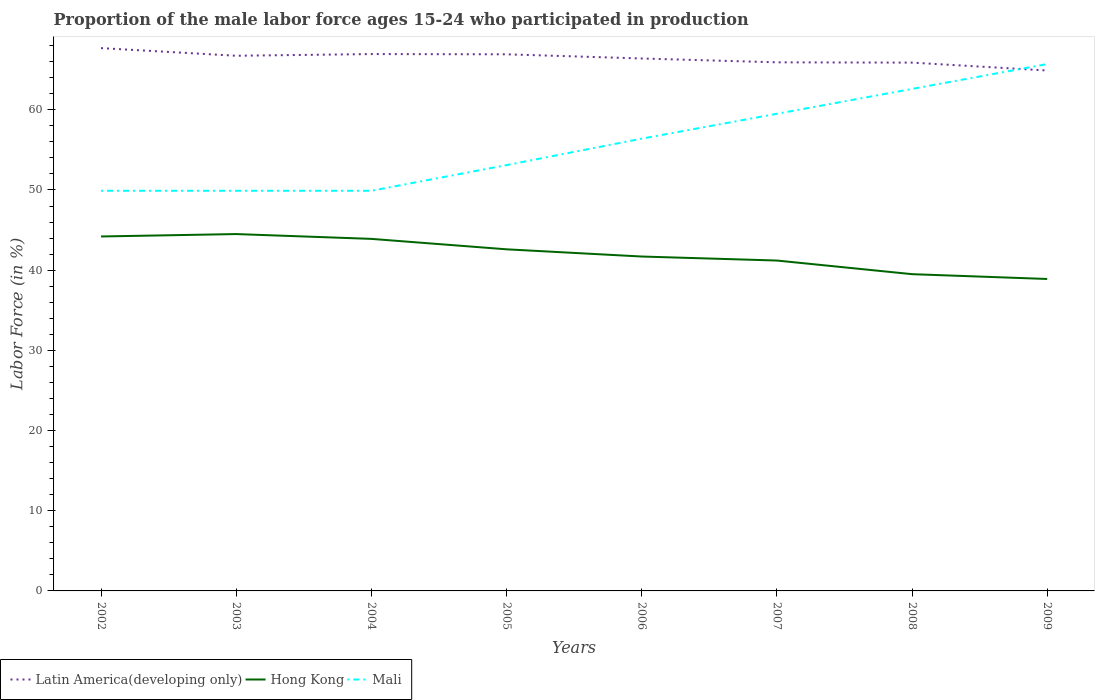How many different coloured lines are there?
Ensure brevity in your answer.  3. Does the line corresponding to Hong Kong intersect with the line corresponding to Latin America(developing only)?
Your response must be concise. No. Across all years, what is the maximum proportion of the male labor force who participated in production in Latin America(developing only)?
Your answer should be compact. 64.9. What is the total proportion of the male labor force who participated in production in Latin America(developing only) in the graph?
Your answer should be compact. 1. What is the difference between the highest and the second highest proportion of the male labor force who participated in production in Hong Kong?
Offer a terse response. 5.6. What is the difference between two consecutive major ticks on the Y-axis?
Offer a terse response. 10. Where does the legend appear in the graph?
Provide a succinct answer. Bottom left. How are the legend labels stacked?
Provide a short and direct response. Horizontal. What is the title of the graph?
Keep it short and to the point. Proportion of the male labor force ages 15-24 who participated in production. What is the label or title of the Y-axis?
Keep it short and to the point. Labor Force (in %). What is the Labor Force (in %) of Latin America(developing only) in 2002?
Give a very brief answer. 67.69. What is the Labor Force (in %) in Hong Kong in 2002?
Make the answer very short. 44.2. What is the Labor Force (in %) of Mali in 2002?
Offer a very short reply. 49.9. What is the Labor Force (in %) in Latin America(developing only) in 2003?
Provide a short and direct response. 66.74. What is the Labor Force (in %) of Hong Kong in 2003?
Your response must be concise. 44.5. What is the Labor Force (in %) in Mali in 2003?
Give a very brief answer. 49.9. What is the Labor Force (in %) in Latin America(developing only) in 2004?
Ensure brevity in your answer.  66.95. What is the Labor Force (in %) in Hong Kong in 2004?
Provide a succinct answer. 43.9. What is the Labor Force (in %) in Mali in 2004?
Ensure brevity in your answer.  49.9. What is the Labor Force (in %) in Latin America(developing only) in 2005?
Give a very brief answer. 66.92. What is the Labor Force (in %) of Hong Kong in 2005?
Your answer should be very brief. 42.6. What is the Labor Force (in %) in Mali in 2005?
Keep it short and to the point. 53.1. What is the Labor Force (in %) in Latin America(developing only) in 2006?
Give a very brief answer. 66.4. What is the Labor Force (in %) in Hong Kong in 2006?
Keep it short and to the point. 41.7. What is the Labor Force (in %) of Mali in 2006?
Offer a terse response. 56.4. What is the Labor Force (in %) in Latin America(developing only) in 2007?
Provide a short and direct response. 65.92. What is the Labor Force (in %) in Hong Kong in 2007?
Provide a succinct answer. 41.2. What is the Labor Force (in %) of Mali in 2007?
Your response must be concise. 59.5. What is the Labor Force (in %) in Latin America(developing only) in 2008?
Provide a short and direct response. 65.88. What is the Labor Force (in %) in Hong Kong in 2008?
Offer a very short reply. 39.5. What is the Labor Force (in %) of Mali in 2008?
Offer a very short reply. 62.6. What is the Labor Force (in %) in Latin America(developing only) in 2009?
Keep it short and to the point. 64.9. What is the Labor Force (in %) of Hong Kong in 2009?
Your answer should be very brief. 38.9. What is the Labor Force (in %) in Mali in 2009?
Give a very brief answer. 65.7. Across all years, what is the maximum Labor Force (in %) of Latin America(developing only)?
Your response must be concise. 67.69. Across all years, what is the maximum Labor Force (in %) of Hong Kong?
Your answer should be compact. 44.5. Across all years, what is the maximum Labor Force (in %) in Mali?
Ensure brevity in your answer.  65.7. Across all years, what is the minimum Labor Force (in %) of Latin America(developing only)?
Offer a very short reply. 64.9. Across all years, what is the minimum Labor Force (in %) of Hong Kong?
Your answer should be compact. 38.9. Across all years, what is the minimum Labor Force (in %) in Mali?
Your answer should be very brief. 49.9. What is the total Labor Force (in %) of Latin America(developing only) in the graph?
Your answer should be compact. 531.38. What is the total Labor Force (in %) in Hong Kong in the graph?
Your answer should be very brief. 336.5. What is the total Labor Force (in %) of Mali in the graph?
Your answer should be very brief. 447. What is the difference between the Labor Force (in %) of Hong Kong in 2002 and that in 2003?
Your answer should be compact. -0.3. What is the difference between the Labor Force (in %) in Mali in 2002 and that in 2003?
Offer a very short reply. 0. What is the difference between the Labor Force (in %) of Latin America(developing only) in 2002 and that in 2004?
Offer a terse response. 0.74. What is the difference between the Labor Force (in %) of Hong Kong in 2002 and that in 2004?
Your answer should be compact. 0.3. What is the difference between the Labor Force (in %) of Latin America(developing only) in 2002 and that in 2005?
Provide a succinct answer. 0.77. What is the difference between the Labor Force (in %) in Latin America(developing only) in 2002 and that in 2006?
Provide a short and direct response. 1.29. What is the difference between the Labor Force (in %) in Mali in 2002 and that in 2006?
Give a very brief answer. -6.5. What is the difference between the Labor Force (in %) of Latin America(developing only) in 2002 and that in 2007?
Offer a very short reply. 1.77. What is the difference between the Labor Force (in %) in Mali in 2002 and that in 2007?
Provide a succinct answer. -9.6. What is the difference between the Labor Force (in %) of Latin America(developing only) in 2002 and that in 2008?
Offer a very short reply. 1.81. What is the difference between the Labor Force (in %) of Mali in 2002 and that in 2008?
Your response must be concise. -12.7. What is the difference between the Labor Force (in %) in Latin America(developing only) in 2002 and that in 2009?
Provide a succinct answer. 2.79. What is the difference between the Labor Force (in %) in Mali in 2002 and that in 2009?
Offer a terse response. -15.8. What is the difference between the Labor Force (in %) of Latin America(developing only) in 2003 and that in 2004?
Offer a terse response. -0.21. What is the difference between the Labor Force (in %) in Hong Kong in 2003 and that in 2004?
Make the answer very short. 0.6. What is the difference between the Labor Force (in %) in Mali in 2003 and that in 2004?
Keep it short and to the point. 0. What is the difference between the Labor Force (in %) of Latin America(developing only) in 2003 and that in 2005?
Provide a short and direct response. -0.18. What is the difference between the Labor Force (in %) in Hong Kong in 2003 and that in 2005?
Offer a terse response. 1.9. What is the difference between the Labor Force (in %) of Latin America(developing only) in 2003 and that in 2006?
Ensure brevity in your answer.  0.34. What is the difference between the Labor Force (in %) of Latin America(developing only) in 2003 and that in 2007?
Offer a terse response. 0.82. What is the difference between the Labor Force (in %) of Hong Kong in 2003 and that in 2007?
Provide a succinct answer. 3.3. What is the difference between the Labor Force (in %) of Mali in 2003 and that in 2007?
Your answer should be compact. -9.6. What is the difference between the Labor Force (in %) of Latin America(developing only) in 2003 and that in 2008?
Give a very brief answer. 0.86. What is the difference between the Labor Force (in %) in Hong Kong in 2003 and that in 2008?
Your response must be concise. 5. What is the difference between the Labor Force (in %) of Mali in 2003 and that in 2008?
Offer a very short reply. -12.7. What is the difference between the Labor Force (in %) in Latin America(developing only) in 2003 and that in 2009?
Offer a very short reply. 1.84. What is the difference between the Labor Force (in %) in Mali in 2003 and that in 2009?
Provide a short and direct response. -15.8. What is the difference between the Labor Force (in %) in Latin America(developing only) in 2004 and that in 2005?
Make the answer very short. 0.03. What is the difference between the Labor Force (in %) in Hong Kong in 2004 and that in 2005?
Give a very brief answer. 1.3. What is the difference between the Labor Force (in %) of Mali in 2004 and that in 2005?
Provide a short and direct response. -3.2. What is the difference between the Labor Force (in %) of Latin America(developing only) in 2004 and that in 2006?
Your answer should be very brief. 0.55. What is the difference between the Labor Force (in %) of Hong Kong in 2004 and that in 2006?
Keep it short and to the point. 2.2. What is the difference between the Labor Force (in %) of Latin America(developing only) in 2004 and that in 2007?
Give a very brief answer. 1.03. What is the difference between the Labor Force (in %) of Latin America(developing only) in 2004 and that in 2008?
Give a very brief answer. 1.07. What is the difference between the Labor Force (in %) of Mali in 2004 and that in 2008?
Your response must be concise. -12.7. What is the difference between the Labor Force (in %) in Latin America(developing only) in 2004 and that in 2009?
Offer a terse response. 2.05. What is the difference between the Labor Force (in %) in Mali in 2004 and that in 2009?
Offer a terse response. -15.8. What is the difference between the Labor Force (in %) of Latin America(developing only) in 2005 and that in 2006?
Offer a very short reply. 0.52. What is the difference between the Labor Force (in %) in Mali in 2005 and that in 2006?
Your response must be concise. -3.3. What is the difference between the Labor Force (in %) of Hong Kong in 2005 and that in 2007?
Make the answer very short. 1.4. What is the difference between the Labor Force (in %) in Mali in 2005 and that in 2007?
Ensure brevity in your answer.  -6.4. What is the difference between the Labor Force (in %) of Latin America(developing only) in 2005 and that in 2008?
Make the answer very short. 1.04. What is the difference between the Labor Force (in %) in Mali in 2005 and that in 2008?
Your answer should be compact. -9.5. What is the difference between the Labor Force (in %) of Latin America(developing only) in 2005 and that in 2009?
Give a very brief answer. 2.02. What is the difference between the Labor Force (in %) of Hong Kong in 2005 and that in 2009?
Offer a very short reply. 3.7. What is the difference between the Labor Force (in %) of Mali in 2005 and that in 2009?
Offer a very short reply. -12.6. What is the difference between the Labor Force (in %) in Latin America(developing only) in 2006 and that in 2007?
Offer a terse response. 0.48. What is the difference between the Labor Force (in %) in Mali in 2006 and that in 2007?
Give a very brief answer. -3.1. What is the difference between the Labor Force (in %) in Latin America(developing only) in 2006 and that in 2008?
Make the answer very short. 0.52. What is the difference between the Labor Force (in %) in Latin America(developing only) in 2006 and that in 2009?
Provide a short and direct response. 1.5. What is the difference between the Labor Force (in %) of Hong Kong in 2006 and that in 2009?
Offer a very short reply. 2.8. What is the difference between the Labor Force (in %) in Latin America(developing only) in 2007 and that in 2008?
Offer a very short reply. 0.04. What is the difference between the Labor Force (in %) of Hong Kong in 2007 and that in 2008?
Offer a very short reply. 1.7. What is the difference between the Labor Force (in %) in Mali in 2007 and that in 2008?
Your answer should be very brief. -3.1. What is the difference between the Labor Force (in %) in Latin America(developing only) in 2007 and that in 2009?
Your answer should be very brief. 1.02. What is the difference between the Labor Force (in %) of Hong Kong in 2007 and that in 2009?
Your response must be concise. 2.3. What is the difference between the Labor Force (in %) of Latin America(developing only) in 2008 and that in 2009?
Your answer should be compact. 0.98. What is the difference between the Labor Force (in %) of Hong Kong in 2008 and that in 2009?
Keep it short and to the point. 0.6. What is the difference between the Labor Force (in %) of Latin America(developing only) in 2002 and the Labor Force (in %) of Hong Kong in 2003?
Offer a terse response. 23.19. What is the difference between the Labor Force (in %) of Latin America(developing only) in 2002 and the Labor Force (in %) of Mali in 2003?
Make the answer very short. 17.79. What is the difference between the Labor Force (in %) in Hong Kong in 2002 and the Labor Force (in %) in Mali in 2003?
Offer a terse response. -5.7. What is the difference between the Labor Force (in %) in Latin America(developing only) in 2002 and the Labor Force (in %) in Hong Kong in 2004?
Provide a succinct answer. 23.79. What is the difference between the Labor Force (in %) of Latin America(developing only) in 2002 and the Labor Force (in %) of Mali in 2004?
Your answer should be compact. 17.79. What is the difference between the Labor Force (in %) of Latin America(developing only) in 2002 and the Labor Force (in %) of Hong Kong in 2005?
Provide a short and direct response. 25.09. What is the difference between the Labor Force (in %) of Latin America(developing only) in 2002 and the Labor Force (in %) of Mali in 2005?
Ensure brevity in your answer.  14.59. What is the difference between the Labor Force (in %) of Latin America(developing only) in 2002 and the Labor Force (in %) of Hong Kong in 2006?
Keep it short and to the point. 25.99. What is the difference between the Labor Force (in %) of Latin America(developing only) in 2002 and the Labor Force (in %) of Mali in 2006?
Your answer should be compact. 11.29. What is the difference between the Labor Force (in %) in Hong Kong in 2002 and the Labor Force (in %) in Mali in 2006?
Make the answer very short. -12.2. What is the difference between the Labor Force (in %) of Latin America(developing only) in 2002 and the Labor Force (in %) of Hong Kong in 2007?
Offer a terse response. 26.49. What is the difference between the Labor Force (in %) in Latin America(developing only) in 2002 and the Labor Force (in %) in Mali in 2007?
Keep it short and to the point. 8.19. What is the difference between the Labor Force (in %) of Hong Kong in 2002 and the Labor Force (in %) of Mali in 2007?
Make the answer very short. -15.3. What is the difference between the Labor Force (in %) of Latin America(developing only) in 2002 and the Labor Force (in %) of Hong Kong in 2008?
Provide a short and direct response. 28.19. What is the difference between the Labor Force (in %) of Latin America(developing only) in 2002 and the Labor Force (in %) of Mali in 2008?
Provide a short and direct response. 5.09. What is the difference between the Labor Force (in %) in Hong Kong in 2002 and the Labor Force (in %) in Mali in 2008?
Provide a succinct answer. -18.4. What is the difference between the Labor Force (in %) of Latin America(developing only) in 2002 and the Labor Force (in %) of Hong Kong in 2009?
Your response must be concise. 28.79. What is the difference between the Labor Force (in %) in Latin America(developing only) in 2002 and the Labor Force (in %) in Mali in 2009?
Ensure brevity in your answer.  1.99. What is the difference between the Labor Force (in %) in Hong Kong in 2002 and the Labor Force (in %) in Mali in 2009?
Ensure brevity in your answer.  -21.5. What is the difference between the Labor Force (in %) in Latin America(developing only) in 2003 and the Labor Force (in %) in Hong Kong in 2004?
Ensure brevity in your answer.  22.84. What is the difference between the Labor Force (in %) in Latin America(developing only) in 2003 and the Labor Force (in %) in Mali in 2004?
Make the answer very short. 16.84. What is the difference between the Labor Force (in %) of Latin America(developing only) in 2003 and the Labor Force (in %) of Hong Kong in 2005?
Provide a succinct answer. 24.14. What is the difference between the Labor Force (in %) in Latin America(developing only) in 2003 and the Labor Force (in %) in Mali in 2005?
Your response must be concise. 13.64. What is the difference between the Labor Force (in %) in Latin America(developing only) in 2003 and the Labor Force (in %) in Hong Kong in 2006?
Your response must be concise. 25.04. What is the difference between the Labor Force (in %) of Latin America(developing only) in 2003 and the Labor Force (in %) of Mali in 2006?
Offer a terse response. 10.34. What is the difference between the Labor Force (in %) in Latin America(developing only) in 2003 and the Labor Force (in %) in Hong Kong in 2007?
Keep it short and to the point. 25.54. What is the difference between the Labor Force (in %) in Latin America(developing only) in 2003 and the Labor Force (in %) in Mali in 2007?
Offer a very short reply. 7.24. What is the difference between the Labor Force (in %) of Latin America(developing only) in 2003 and the Labor Force (in %) of Hong Kong in 2008?
Make the answer very short. 27.24. What is the difference between the Labor Force (in %) in Latin America(developing only) in 2003 and the Labor Force (in %) in Mali in 2008?
Give a very brief answer. 4.14. What is the difference between the Labor Force (in %) of Hong Kong in 2003 and the Labor Force (in %) of Mali in 2008?
Your answer should be compact. -18.1. What is the difference between the Labor Force (in %) in Latin America(developing only) in 2003 and the Labor Force (in %) in Hong Kong in 2009?
Provide a short and direct response. 27.84. What is the difference between the Labor Force (in %) in Latin America(developing only) in 2003 and the Labor Force (in %) in Mali in 2009?
Keep it short and to the point. 1.04. What is the difference between the Labor Force (in %) of Hong Kong in 2003 and the Labor Force (in %) of Mali in 2009?
Provide a succinct answer. -21.2. What is the difference between the Labor Force (in %) in Latin America(developing only) in 2004 and the Labor Force (in %) in Hong Kong in 2005?
Offer a very short reply. 24.35. What is the difference between the Labor Force (in %) in Latin America(developing only) in 2004 and the Labor Force (in %) in Mali in 2005?
Offer a terse response. 13.85. What is the difference between the Labor Force (in %) in Hong Kong in 2004 and the Labor Force (in %) in Mali in 2005?
Ensure brevity in your answer.  -9.2. What is the difference between the Labor Force (in %) in Latin America(developing only) in 2004 and the Labor Force (in %) in Hong Kong in 2006?
Your answer should be very brief. 25.25. What is the difference between the Labor Force (in %) in Latin America(developing only) in 2004 and the Labor Force (in %) in Mali in 2006?
Make the answer very short. 10.55. What is the difference between the Labor Force (in %) in Latin America(developing only) in 2004 and the Labor Force (in %) in Hong Kong in 2007?
Provide a succinct answer. 25.75. What is the difference between the Labor Force (in %) of Latin America(developing only) in 2004 and the Labor Force (in %) of Mali in 2007?
Give a very brief answer. 7.45. What is the difference between the Labor Force (in %) in Hong Kong in 2004 and the Labor Force (in %) in Mali in 2007?
Your answer should be compact. -15.6. What is the difference between the Labor Force (in %) of Latin America(developing only) in 2004 and the Labor Force (in %) of Hong Kong in 2008?
Keep it short and to the point. 27.45. What is the difference between the Labor Force (in %) of Latin America(developing only) in 2004 and the Labor Force (in %) of Mali in 2008?
Your response must be concise. 4.35. What is the difference between the Labor Force (in %) of Hong Kong in 2004 and the Labor Force (in %) of Mali in 2008?
Provide a succinct answer. -18.7. What is the difference between the Labor Force (in %) of Latin America(developing only) in 2004 and the Labor Force (in %) of Hong Kong in 2009?
Give a very brief answer. 28.05. What is the difference between the Labor Force (in %) of Latin America(developing only) in 2004 and the Labor Force (in %) of Mali in 2009?
Your response must be concise. 1.25. What is the difference between the Labor Force (in %) of Hong Kong in 2004 and the Labor Force (in %) of Mali in 2009?
Your answer should be compact. -21.8. What is the difference between the Labor Force (in %) in Latin America(developing only) in 2005 and the Labor Force (in %) in Hong Kong in 2006?
Your response must be concise. 25.22. What is the difference between the Labor Force (in %) of Latin America(developing only) in 2005 and the Labor Force (in %) of Mali in 2006?
Keep it short and to the point. 10.52. What is the difference between the Labor Force (in %) in Hong Kong in 2005 and the Labor Force (in %) in Mali in 2006?
Provide a short and direct response. -13.8. What is the difference between the Labor Force (in %) in Latin America(developing only) in 2005 and the Labor Force (in %) in Hong Kong in 2007?
Offer a very short reply. 25.72. What is the difference between the Labor Force (in %) of Latin America(developing only) in 2005 and the Labor Force (in %) of Mali in 2007?
Give a very brief answer. 7.42. What is the difference between the Labor Force (in %) of Hong Kong in 2005 and the Labor Force (in %) of Mali in 2007?
Provide a succinct answer. -16.9. What is the difference between the Labor Force (in %) in Latin America(developing only) in 2005 and the Labor Force (in %) in Hong Kong in 2008?
Your answer should be very brief. 27.42. What is the difference between the Labor Force (in %) in Latin America(developing only) in 2005 and the Labor Force (in %) in Mali in 2008?
Give a very brief answer. 4.32. What is the difference between the Labor Force (in %) of Latin America(developing only) in 2005 and the Labor Force (in %) of Hong Kong in 2009?
Your answer should be compact. 28.02. What is the difference between the Labor Force (in %) of Latin America(developing only) in 2005 and the Labor Force (in %) of Mali in 2009?
Offer a terse response. 1.22. What is the difference between the Labor Force (in %) of Hong Kong in 2005 and the Labor Force (in %) of Mali in 2009?
Keep it short and to the point. -23.1. What is the difference between the Labor Force (in %) of Latin America(developing only) in 2006 and the Labor Force (in %) of Hong Kong in 2007?
Keep it short and to the point. 25.2. What is the difference between the Labor Force (in %) of Latin America(developing only) in 2006 and the Labor Force (in %) of Mali in 2007?
Your answer should be compact. 6.9. What is the difference between the Labor Force (in %) in Hong Kong in 2006 and the Labor Force (in %) in Mali in 2007?
Your response must be concise. -17.8. What is the difference between the Labor Force (in %) in Latin America(developing only) in 2006 and the Labor Force (in %) in Hong Kong in 2008?
Provide a short and direct response. 26.9. What is the difference between the Labor Force (in %) of Latin America(developing only) in 2006 and the Labor Force (in %) of Mali in 2008?
Provide a succinct answer. 3.8. What is the difference between the Labor Force (in %) in Hong Kong in 2006 and the Labor Force (in %) in Mali in 2008?
Give a very brief answer. -20.9. What is the difference between the Labor Force (in %) in Latin America(developing only) in 2006 and the Labor Force (in %) in Hong Kong in 2009?
Your response must be concise. 27.5. What is the difference between the Labor Force (in %) of Latin America(developing only) in 2006 and the Labor Force (in %) of Mali in 2009?
Keep it short and to the point. 0.7. What is the difference between the Labor Force (in %) in Latin America(developing only) in 2007 and the Labor Force (in %) in Hong Kong in 2008?
Make the answer very short. 26.42. What is the difference between the Labor Force (in %) in Latin America(developing only) in 2007 and the Labor Force (in %) in Mali in 2008?
Offer a terse response. 3.32. What is the difference between the Labor Force (in %) of Hong Kong in 2007 and the Labor Force (in %) of Mali in 2008?
Offer a very short reply. -21.4. What is the difference between the Labor Force (in %) in Latin America(developing only) in 2007 and the Labor Force (in %) in Hong Kong in 2009?
Ensure brevity in your answer.  27.02. What is the difference between the Labor Force (in %) of Latin America(developing only) in 2007 and the Labor Force (in %) of Mali in 2009?
Ensure brevity in your answer.  0.22. What is the difference between the Labor Force (in %) in Hong Kong in 2007 and the Labor Force (in %) in Mali in 2009?
Keep it short and to the point. -24.5. What is the difference between the Labor Force (in %) in Latin America(developing only) in 2008 and the Labor Force (in %) in Hong Kong in 2009?
Give a very brief answer. 26.98. What is the difference between the Labor Force (in %) of Latin America(developing only) in 2008 and the Labor Force (in %) of Mali in 2009?
Offer a terse response. 0.18. What is the difference between the Labor Force (in %) of Hong Kong in 2008 and the Labor Force (in %) of Mali in 2009?
Offer a terse response. -26.2. What is the average Labor Force (in %) of Latin America(developing only) per year?
Your answer should be compact. 66.42. What is the average Labor Force (in %) of Hong Kong per year?
Ensure brevity in your answer.  42.06. What is the average Labor Force (in %) in Mali per year?
Offer a terse response. 55.88. In the year 2002, what is the difference between the Labor Force (in %) of Latin America(developing only) and Labor Force (in %) of Hong Kong?
Offer a terse response. 23.49. In the year 2002, what is the difference between the Labor Force (in %) of Latin America(developing only) and Labor Force (in %) of Mali?
Your answer should be compact. 17.79. In the year 2003, what is the difference between the Labor Force (in %) of Latin America(developing only) and Labor Force (in %) of Hong Kong?
Ensure brevity in your answer.  22.24. In the year 2003, what is the difference between the Labor Force (in %) of Latin America(developing only) and Labor Force (in %) of Mali?
Your answer should be very brief. 16.84. In the year 2004, what is the difference between the Labor Force (in %) in Latin America(developing only) and Labor Force (in %) in Hong Kong?
Provide a succinct answer. 23.05. In the year 2004, what is the difference between the Labor Force (in %) in Latin America(developing only) and Labor Force (in %) in Mali?
Ensure brevity in your answer.  17.05. In the year 2004, what is the difference between the Labor Force (in %) of Hong Kong and Labor Force (in %) of Mali?
Your answer should be very brief. -6. In the year 2005, what is the difference between the Labor Force (in %) in Latin America(developing only) and Labor Force (in %) in Hong Kong?
Ensure brevity in your answer.  24.32. In the year 2005, what is the difference between the Labor Force (in %) of Latin America(developing only) and Labor Force (in %) of Mali?
Keep it short and to the point. 13.82. In the year 2005, what is the difference between the Labor Force (in %) in Hong Kong and Labor Force (in %) in Mali?
Your answer should be compact. -10.5. In the year 2006, what is the difference between the Labor Force (in %) of Latin America(developing only) and Labor Force (in %) of Hong Kong?
Your answer should be compact. 24.7. In the year 2006, what is the difference between the Labor Force (in %) in Latin America(developing only) and Labor Force (in %) in Mali?
Make the answer very short. 10. In the year 2006, what is the difference between the Labor Force (in %) of Hong Kong and Labor Force (in %) of Mali?
Provide a short and direct response. -14.7. In the year 2007, what is the difference between the Labor Force (in %) of Latin America(developing only) and Labor Force (in %) of Hong Kong?
Keep it short and to the point. 24.72. In the year 2007, what is the difference between the Labor Force (in %) of Latin America(developing only) and Labor Force (in %) of Mali?
Your response must be concise. 6.42. In the year 2007, what is the difference between the Labor Force (in %) of Hong Kong and Labor Force (in %) of Mali?
Offer a very short reply. -18.3. In the year 2008, what is the difference between the Labor Force (in %) of Latin America(developing only) and Labor Force (in %) of Hong Kong?
Provide a short and direct response. 26.38. In the year 2008, what is the difference between the Labor Force (in %) of Latin America(developing only) and Labor Force (in %) of Mali?
Give a very brief answer. 3.28. In the year 2008, what is the difference between the Labor Force (in %) in Hong Kong and Labor Force (in %) in Mali?
Make the answer very short. -23.1. In the year 2009, what is the difference between the Labor Force (in %) in Latin America(developing only) and Labor Force (in %) in Hong Kong?
Give a very brief answer. 26. In the year 2009, what is the difference between the Labor Force (in %) of Latin America(developing only) and Labor Force (in %) of Mali?
Make the answer very short. -0.8. In the year 2009, what is the difference between the Labor Force (in %) in Hong Kong and Labor Force (in %) in Mali?
Your answer should be very brief. -26.8. What is the ratio of the Labor Force (in %) in Latin America(developing only) in 2002 to that in 2003?
Give a very brief answer. 1.01. What is the ratio of the Labor Force (in %) of Mali in 2002 to that in 2003?
Provide a short and direct response. 1. What is the ratio of the Labor Force (in %) of Latin America(developing only) in 2002 to that in 2004?
Ensure brevity in your answer.  1.01. What is the ratio of the Labor Force (in %) in Hong Kong in 2002 to that in 2004?
Ensure brevity in your answer.  1.01. What is the ratio of the Labor Force (in %) of Mali in 2002 to that in 2004?
Offer a very short reply. 1. What is the ratio of the Labor Force (in %) in Latin America(developing only) in 2002 to that in 2005?
Provide a short and direct response. 1.01. What is the ratio of the Labor Force (in %) in Hong Kong in 2002 to that in 2005?
Your answer should be very brief. 1.04. What is the ratio of the Labor Force (in %) of Mali in 2002 to that in 2005?
Your response must be concise. 0.94. What is the ratio of the Labor Force (in %) of Latin America(developing only) in 2002 to that in 2006?
Your response must be concise. 1.02. What is the ratio of the Labor Force (in %) of Hong Kong in 2002 to that in 2006?
Your response must be concise. 1.06. What is the ratio of the Labor Force (in %) of Mali in 2002 to that in 2006?
Give a very brief answer. 0.88. What is the ratio of the Labor Force (in %) of Latin America(developing only) in 2002 to that in 2007?
Make the answer very short. 1.03. What is the ratio of the Labor Force (in %) of Hong Kong in 2002 to that in 2007?
Give a very brief answer. 1.07. What is the ratio of the Labor Force (in %) in Mali in 2002 to that in 2007?
Your response must be concise. 0.84. What is the ratio of the Labor Force (in %) of Latin America(developing only) in 2002 to that in 2008?
Provide a succinct answer. 1.03. What is the ratio of the Labor Force (in %) in Hong Kong in 2002 to that in 2008?
Give a very brief answer. 1.12. What is the ratio of the Labor Force (in %) in Mali in 2002 to that in 2008?
Your response must be concise. 0.8. What is the ratio of the Labor Force (in %) of Latin America(developing only) in 2002 to that in 2009?
Provide a short and direct response. 1.04. What is the ratio of the Labor Force (in %) in Hong Kong in 2002 to that in 2009?
Give a very brief answer. 1.14. What is the ratio of the Labor Force (in %) of Mali in 2002 to that in 2009?
Give a very brief answer. 0.76. What is the ratio of the Labor Force (in %) in Hong Kong in 2003 to that in 2004?
Provide a succinct answer. 1.01. What is the ratio of the Labor Force (in %) of Mali in 2003 to that in 2004?
Offer a terse response. 1. What is the ratio of the Labor Force (in %) of Latin America(developing only) in 2003 to that in 2005?
Ensure brevity in your answer.  1. What is the ratio of the Labor Force (in %) of Hong Kong in 2003 to that in 2005?
Your answer should be compact. 1.04. What is the ratio of the Labor Force (in %) of Mali in 2003 to that in 2005?
Your answer should be compact. 0.94. What is the ratio of the Labor Force (in %) of Hong Kong in 2003 to that in 2006?
Provide a succinct answer. 1.07. What is the ratio of the Labor Force (in %) of Mali in 2003 to that in 2006?
Your response must be concise. 0.88. What is the ratio of the Labor Force (in %) in Latin America(developing only) in 2003 to that in 2007?
Give a very brief answer. 1.01. What is the ratio of the Labor Force (in %) of Hong Kong in 2003 to that in 2007?
Offer a very short reply. 1.08. What is the ratio of the Labor Force (in %) of Mali in 2003 to that in 2007?
Your answer should be very brief. 0.84. What is the ratio of the Labor Force (in %) of Latin America(developing only) in 2003 to that in 2008?
Make the answer very short. 1.01. What is the ratio of the Labor Force (in %) of Hong Kong in 2003 to that in 2008?
Provide a short and direct response. 1.13. What is the ratio of the Labor Force (in %) of Mali in 2003 to that in 2008?
Keep it short and to the point. 0.8. What is the ratio of the Labor Force (in %) of Latin America(developing only) in 2003 to that in 2009?
Keep it short and to the point. 1.03. What is the ratio of the Labor Force (in %) of Hong Kong in 2003 to that in 2009?
Make the answer very short. 1.14. What is the ratio of the Labor Force (in %) of Mali in 2003 to that in 2009?
Offer a terse response. 0.76. What is the ratio of the Labor Force (in %) of Latin America(developing only) in 2004 to that in 2005?
Your answer should be compact. 1. What is the ratio of the Labor Force (in %) in Hong Kong in 2004 to that in 2005?
Keep it short and to the point. 1.03. What is the ratio of the Labor Force (in %) of Mali in 2004 to that in 2005?
Keep it short and to the point. 0.94. What is the ratio of the Labor Force (in %) in Latin America(developing only) in 2004 to that in 2006?
Offer a terse response. 1.01. What is the ratio of the Labor Force (in %) of Hong Kong in 2004 to that in 2006?
Provide a short and direct response. 1.05. What is the ratio of the Labor Force (in %) of Mali in 2004 to that in 2006?
Your answer should be compact. 0.88. What is the ratio of the Labor Force (in %) in Latin America(developing only) in 2004 to that in 2007?
Keep it short and to the point. 1.02. What is the ratio of the Labor Force (in %) of Hong Kong in 2004 to that in 2007?
Offer a very short reply. 1.07. What is the ratio of the Labor Force (in %) in Mali in 2004 to that in 2007?
Ensure brevity in your answer.  0.84. What is the ratio of the Labor Force (in %) of Latin America(developing only) in 2004 to that in 2008?
Your answer should be compact. 1.02. What is the ratio of the Labor Force (in %) in Hong Kong in 2004 to that in 2008?
Offer a very short reply. 1.11. What is the ratio of the Labor Force (in %) in Mali in 2004 to that in 2008?
Your answer should be compact. 0.8. What is the ratio of the Labor Force (in %) of Latin America(developing only) in 2004 to that in 2009?
Give a very brief answer. 1.03. What is the ratio of the Labor Force (in %) in Hong Kong in 2004 to that in 2009?
Provide a succinct answer. 1.13. What is the ratio of the Labor Force (in %) of Mali in 2004 to that in 2009?
Offer a terse response. 0.76. What is the ratio of the Labor Force (in %) in Hong Kong in 2005 to that in 2006?
Your answer should be compact. 1.02. What is the ratio of the Labor Force (in %) of Mali in 2005 to that in 2006?
Your response must be concise. 0.94. What is the ratio of the Labor Force (in %) of Latin America(developing only) in 2005 to that in 2007?
Provide a short and direct response. 1.02. What is the ratio of the Labor Force (in %) in Hong Kong in 2005 to that in 2007?
Offer a terse response. 1.03. What is the ratio of the Labor Force (in %) in Mali in 2005 to that in 2007?
Make the answer very short. 0.89. What is the ratio of the Labor Force (in %) in Latin America(developing only) in 2005 to that in 2008?
Provide a succinct answer. 1.02. What is the ratio of the Labor Force (in %) of Hong Kong in 2005 to that in 2008?
Offer a very short reply. 1.08. What is the ratio of the Labor Force (in %) in Mali in 2005 to that in 2008?
Give a very brief answer. 0.85. What is the ratio of the Labor Force (in %) of Latin America(developing only) in 2005 to that in 2009?
Offer a terse response. 1.03. What is the ratio of the Labor Force (in %) in Hong Kong in 2005 to that in 2009?
Keep it short and to the point. 1.1. What is the ratio of the Labor Force (in %) of Mali in 2005 to that in 2009?
Keep it short and to the point. 0.81. What is the ratio of the Labor Force (in %) in Latin America(developing only) in 2006 to that in 2007?
Give a very brief answer. 1.01. What is the ratio of the Labor Force (in %) of Hong Kong in 2006 to that in 2007?
Keep it short and to the point. 1.01. What is the ratio of the Labor Force (in %) of Mali in 2006 to that in 2007?
Your answer should be compact. 0.95. What is the ratio of the Labor Force (in %) of Latin America(developing only) in 2006 to that in 2008?
Offer a very short reply. 1.01. What is the ratio of the Labor Force (in %) of Hong Kong in 2006 to that in 2008?
Make the answer very short. 1.06. What is the ratio of the Labor Force (in %) in Mali in 2006 to that in 2008?
Make the answer very short. 0.9. What is the ratio of the Labor Force (in %) of Latin America(developing only) in 2006 to that in 2009?
Give a very brief answer. 1.02. What is the ratio of the Labor Force (in %) of Hong Kong in 2006 to that in 2009?
Provide a short and direct response. 1.07. What is the ratio of the Labor Force (in %) in Mali in 2006 to that in 2009?
Ensure brevity in your answer.  0.86. What is the ratio of the Labor Force (in %) in Latin America(developing only) in 2007 to that in 2008?
Give a very brief answer. 1. What is the ratio of the Labor Force (in %) of Hong Kong in 2007 to that in 2008?
Offer a terse response. 1.04. What is the ratio of the Labor Force (in %) of Mali in 2007 to that in 2008?
Your answer should be compact. 0.95. What is the ratio of the Labor Force (in %) of Latin America(developing only) in 2007 to that in 2009?
Your response must be concise. 1.02. What is the ratio of the Labor Force (in %) in Hong Kong in 2007 to that in 2009?
Ensure brevity in your answer.  1.06. What is the ratio of the Labor Force (in %) of Mali in 2007 to that in 2009?
Keep it short and to the point. 0.91. What is the ratio of the Labor Force (in %) in Latin America(developing only) in 2008 to that in 2009?
Your response must be concise. 1.02. What is the ratio of the Labor Force (in %) of Hong Kong in 2008 to that in 2009?
Offer a terse response. 1.02. What is the ratio of the Labor Force (in %) of Mali in 2008 to that in 2009?
Your response must be concise. 0.95. What is the difference between the highest and the second highest Labor Force (in %) of Latin America(developing only)?
Keep it short and to the point. 0.74. What is the difference between the highest and the second highest Labor Force (in %) of Hong Kong?
Your response must be concise. 0.3. What is the difference between the highest and the lowest Labor Force (in %) in Latin America(developing only)?
Offer a terse response. 2.79. What is the difference between the highest and the lowest Labor Force (in %) of Hong Kong?
Make the answer very short. 5.6. 